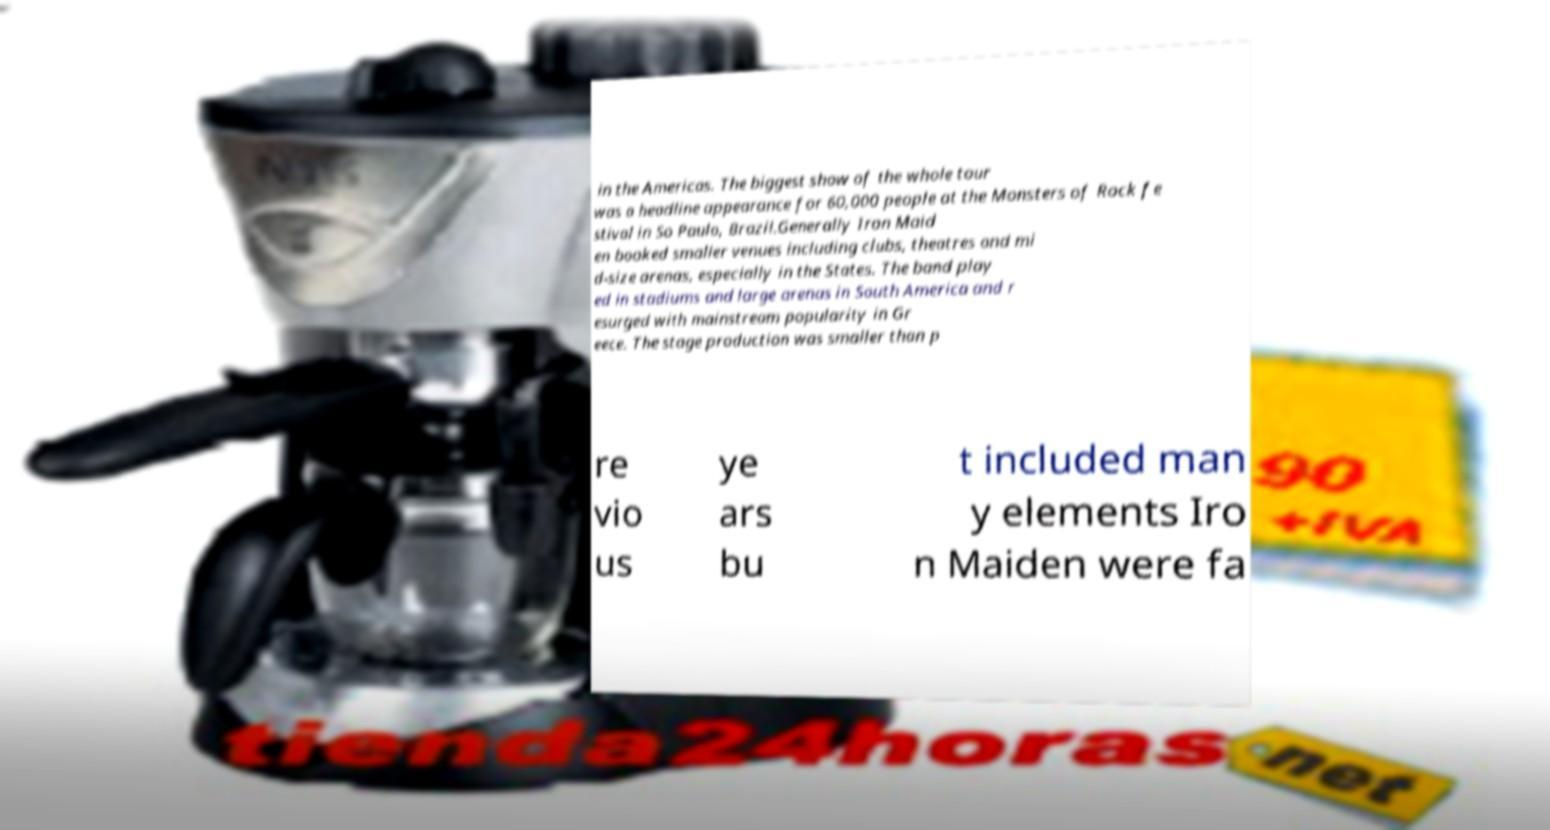There's text embedded in this image that I need extracted. Can you transcribe it verbatim? in the Americas. The biggest show of the whole tour was a headline appearance for 60,000 people at the Monsters of Rock fe stival in So Paulo, Brazil.Generally Iron Maid en booked smaller venues including clubs, theatres and mi d-size arenas, especially in the States. The band play ed in stadiums and large arenas in South America and r esurged with mainstream popularity in Gr eece. The stage production was smaller than p re vio us ye ars bu t included man y elements Iro n Maiden were fa 